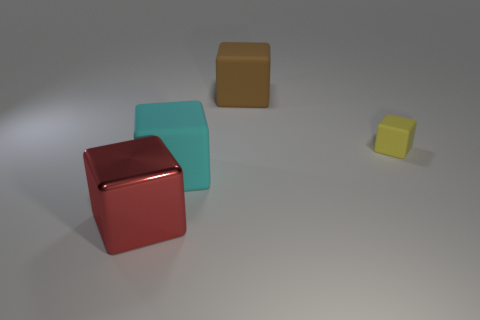Are the tiny yellow thing and the big red thing made of the same material?
Offer a very short reply. No. The tiny rubber thing that is the same shape as the big red metallic thing is what color?
Your response must be concise. Yellow. There is a rubber cube that is left of the brown rubber thing; is it the same color as the tiny matte object?
Ensure brevity in your answer.  No. How many cyan things are the same material as the tiny yellow block?
Your answer should be compact. 1. There is a large red thing; what number of cyan things are behind it?
Make the answer very short. 1. The cyan matte block has what size?
Give a very brief answer. Large. What is the color of the metal cube that is the same size as the cyan thing?
Offer a terse response. Red. Are there any large metal cubes of the same color as the small matte block?
Offer a very short reply. No. What is the tiny yellow thing made of?
Provide a succinct answer. Rubber. How many large matte things are there?
Make the answer very short. 2. 